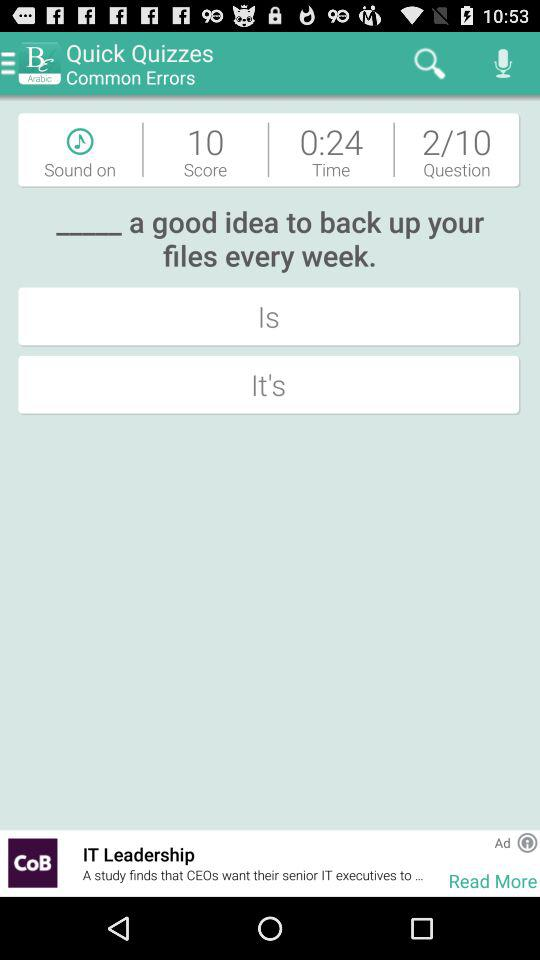Which question is currently shown out of ten? Out of ten, the second question is shown. 